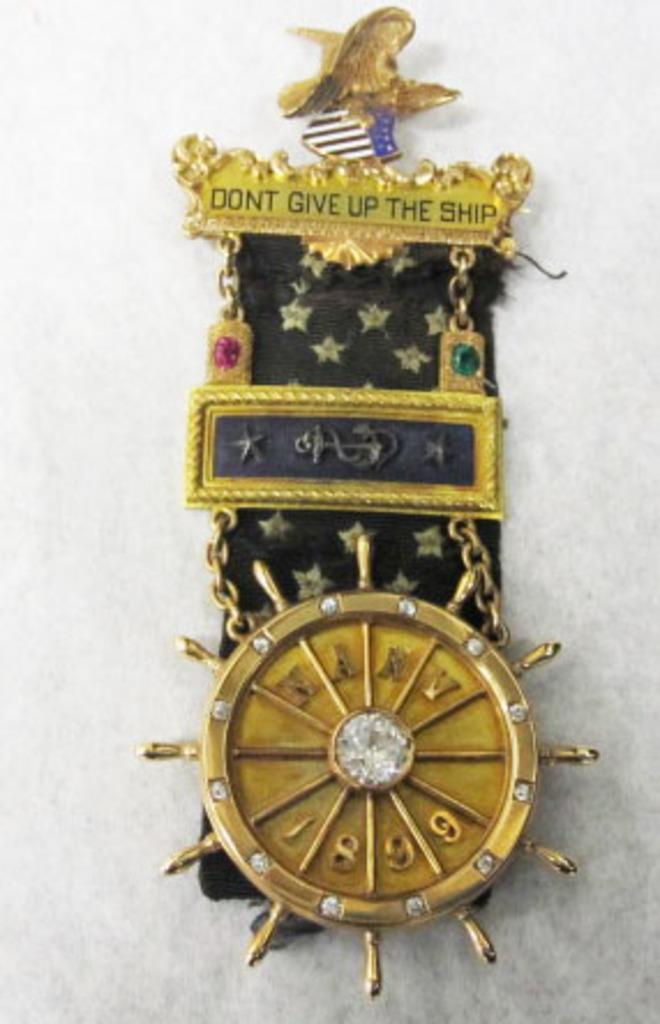<image>
Provide a brief description of the given image. a watch that says to not give up the ship 